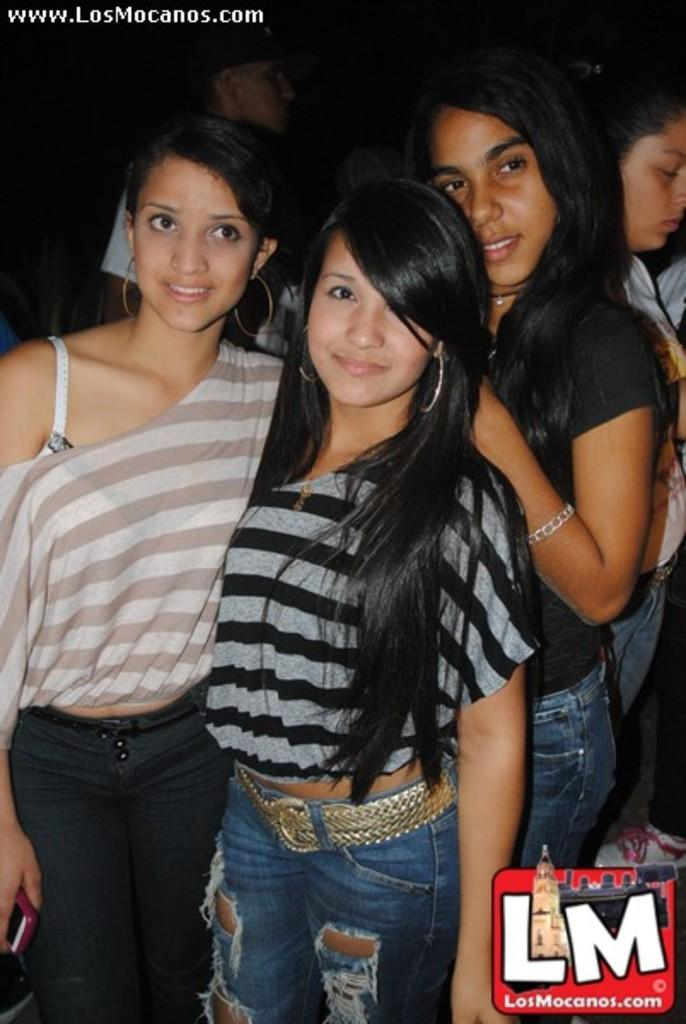How many women are in the image? There are three women in the image. What are the women doing in the image? The women are posing for a camera. Can you describe the background of the image? The background of the image is dark. Are there any other people in the image besides the women? Yes, there are two other persons in the image. What else can be seen in the image? The image contains a logo. What type of bell can be heard ringing in the image? There is no bell present in the image, and therefore no sound can be heard. Can you describe the cow that is grazing in the background of the image? There is no cow present in the image; the background is dark. 